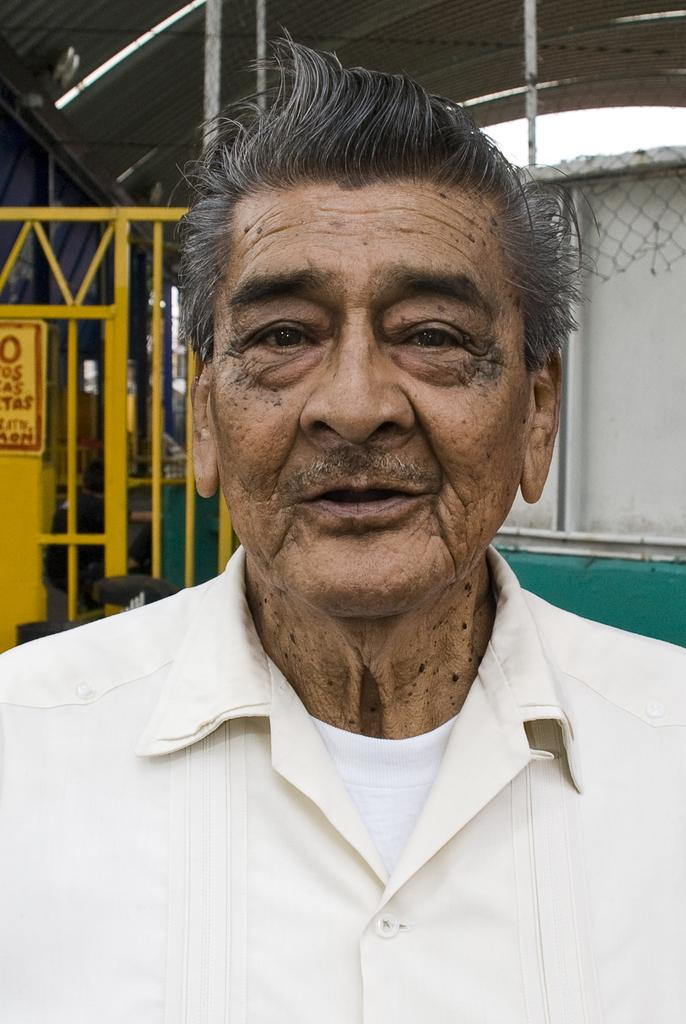Who is present in the image? There is a man in the image. What is the man wearing? The man is wearing a white shirt. What can be seen behind the man? There are metal rods visible behind the man. What type of structure is present in the image? There is a shed in the image. What sense does the man appear to be using in the image? The image does not provide information about the man's senses or how he is using them. 